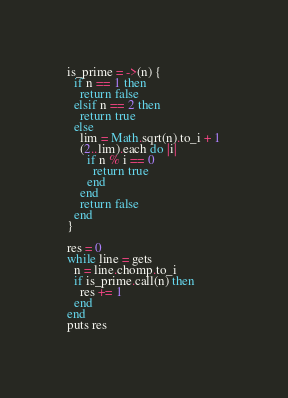<code> <loc_0><loc_0><loc_500><loc_500><_Ruby_>is_prime = ->(n) {
  if n == 1 then
    return false
  elsif n == 2 then
    return true
  else
    lim = Math.sqrt(n).to_i + 1
    (2..lim).each do |i|
      if n % i == 0
        return true
      end
    end
    return false
  end
}

res = 0
while line = gets
  n = line.chomp.to_i
  if is_prime.call(n) then
    res += 1
  end
end
puts res</code> 